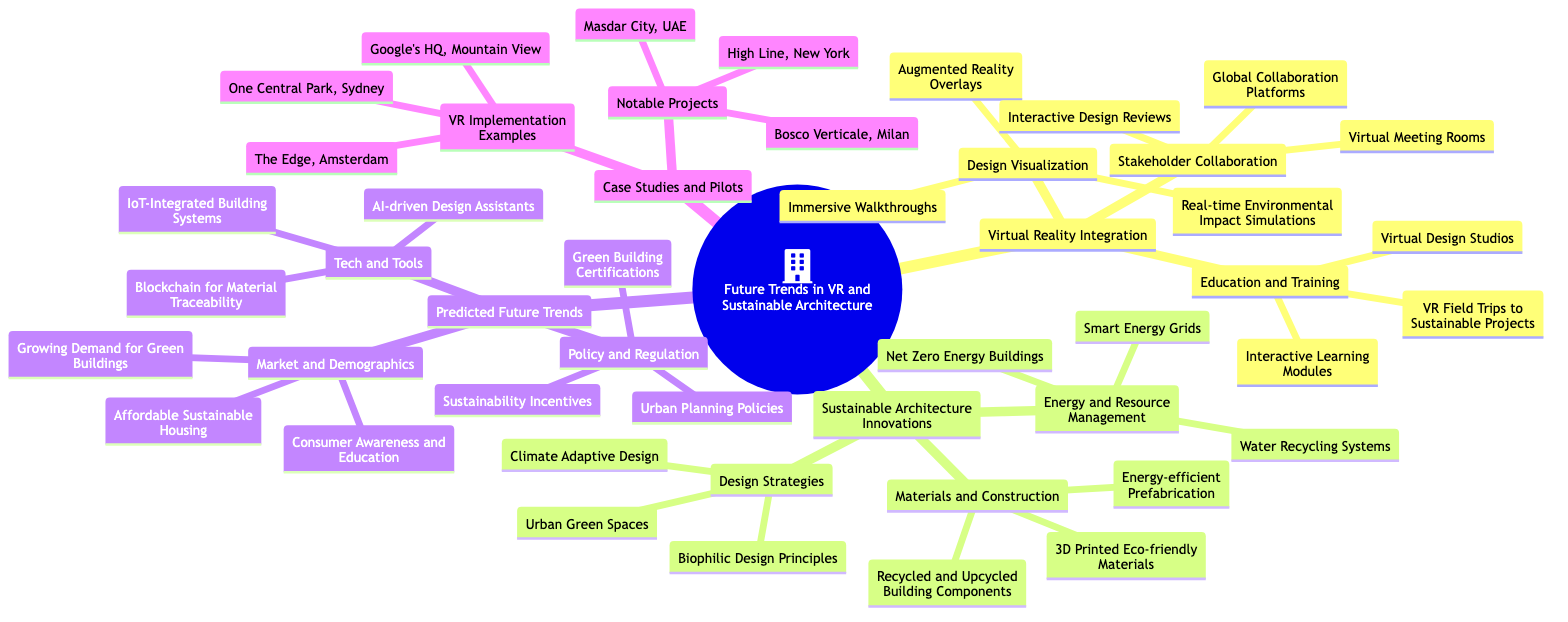What is one application of Virtual Reality in Design Visualization? The diagram lists three applications, with "Immersive Walkthroughs" being one of them under the "Design Visualization" node.
Answer: Immersive Walkthroughs How many main categories are there under "Future Trends in VR and Sustainable Architecture"? The main categories listed in the diagram are "Virtual Reality Integration", "Sustainable Architecture Innovations", "Predicted Future Trends", and "Case Studies and Pilots", totaling four categories.
Answer: 4 What is a notable project mentioned in the "Case Studies and Pilots"? Under the "Notable Projects" node, "Bosco Verticale, Milan" is highlighted as a significant example.
Answer: Bosco Verticale, Milan What type of building system is mentioned under "Energy and Resource Management"? The node lists "Smart Energy Grids" specifically under the "Energy and Resource Management" category.
Answer: Smart Energy Grids Which technology is predicted to aid in design among future trends? The "Tech and Tools" category lists "AI-driven Design Assistants" as a prediction for future trends in architecture and design.
Answer: AI-driven Design Assistants How are Virtual Reality and Sustainable Architecture connected based on the diagram? The relationship is established through the integration of Virtual Reality in various aspects of Sustainable Architecture, such as Design Visualization and Stakeholder Collaboration, demonstrating how VR enhances sustainable design practices.
Answer: Integration of VR in design practices What type of design principles are included in "Design Strategies"? The diagram mentions "Biophilic Design Principles" under the "Design Strategies" node, which focuses on the connection between humans and nature in architectural design.
Answer: Biophilic Design Principles What is one example of a VR Implementation mentioned? The diagram presents "Google's HQ, Mountain View" as one instance of how Virtual Reality has been implemented in architecture.
Answer: Google's HQ, Mountain View What is one emerging market trend identified in the future predictions? Among the trends listed under "Market and Demographics", "Growing Demand for Green Buildings" highlights an increasing interest in environmentally sustainable architecture.
Answer: Growing Demand for Green Buildings 